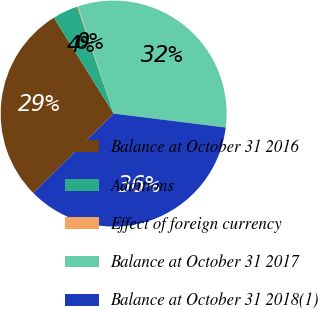Convert chart to OTSL. <chart><loc_0><loc_0><loc_500><loc_500><pie_chart><fcel>Balance at October 31 2016<fcel>Additions<fcel>Effect of foreign currency<fcel>Balance at October 31 2017<fcel>Balance at October 31 2018(1)<nl><fcel>28.52%<fcel>3.66%<fcel>0.12%<fcel>32.07%<fcel>35.62%<nl></chart> 